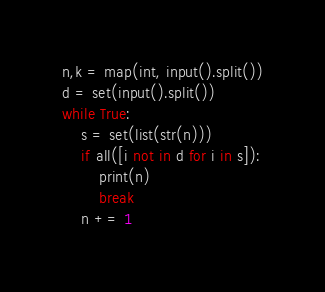Convert code to text. <code><loc_0><loc_0><loc_500><loc_500><_Python_>n,k = map(int, input().split())
d = set(input().split())
while True:
    s = set(list(str(n)))
    if all([i not in d for i in s]):
        print(n)
        break
    n += 1</code> 